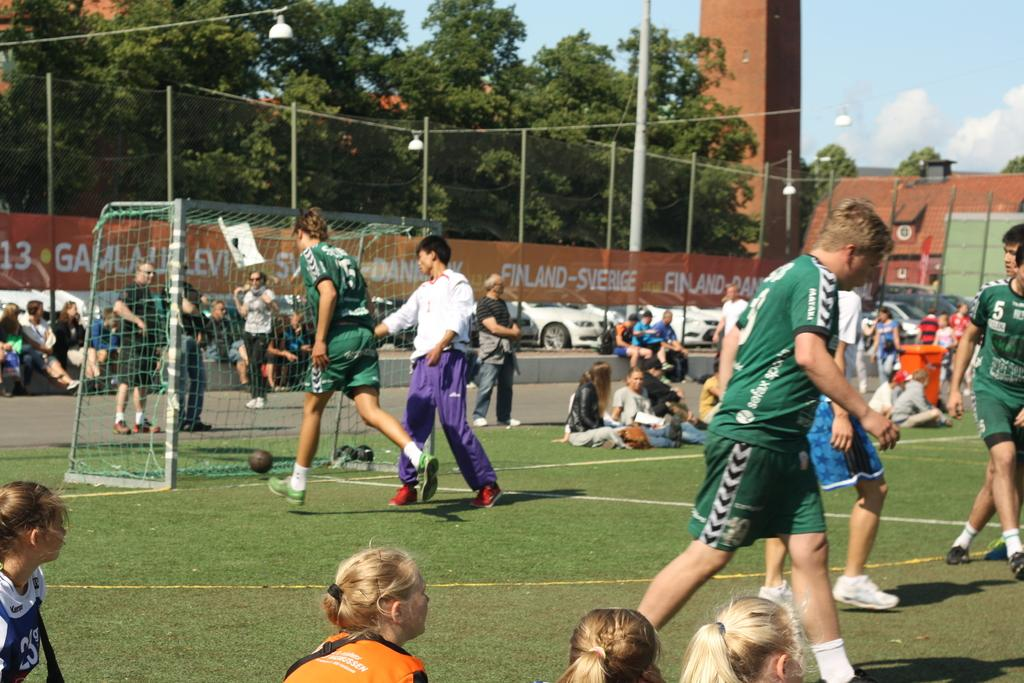<image>
Give a short and clear explanation of the subsequent image. Many people on a sports field in front of a sign that says Finland-Sverige. 